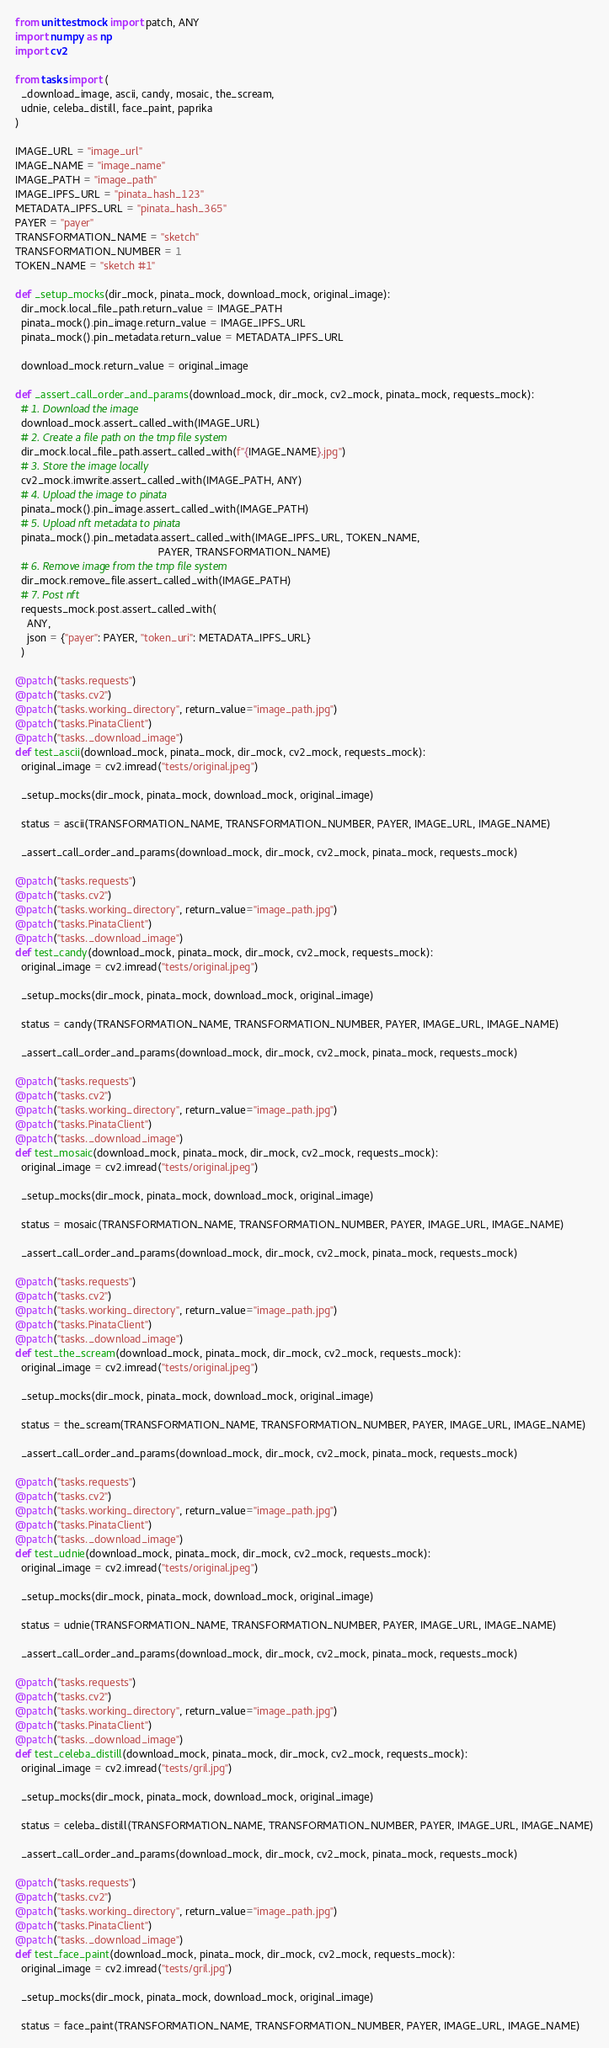<code> <loc_0><loc_0><loc_500><loc_500><_Python_>from unittest.mock import patch, ANY
import numpy as np
import cv2

from tasks import (
  _download_image, ascii, candy, mosaic, the_scream,
  udnie, celeba_distill, face_paint, paprika
)

IMAGE_URL = "image_url"
IMAGE_NAME = "image_name"
IMAGE_PATH = "image_path"
IMAGE_IPFS_URL = "pinata_hash_123"
METADATA_IPFS_URL = "pinata_hash_365"
PAYER = "payer"
TRANSFORMATION_NAME = "sketch"
TRANSFORMATION_NUMBER = 1
TOKEN_NAME = "sketch #1"

def _setup_mocks(dir_mock, pinata_mock, download_mock, original_image):
  dir_mock.local_file_path.return_value = IMAGE_PATH
  pinata_mock().pin_image.return_value = IMAGE_IPFS_URL
  pinata_mock().pin_metadata.return_value = METADATA_IPFS_URL

  download_mock.return_value = original_image

def _assert_call_order_and_params(download_mock, dir_mock, cv2_mock, pinata_mock, requests_mock):
  # 1. Download the image
  download_mock.assert_called_with(IMAGE_URL)
  # 2. Create a file path on the tmp file system
  dir_mock.local_file_path.assert_called_with(f"{IMAGE_NAME}.jpg")
  # 3. Store the image locally
  cv2_mock.imwrite.assert_called_with(IMAGE_PATH, ANY)
  # 4. Upload the image to pinata
  pinata_mock().pin_image.assert_called_with(IMAGE_PATH)
  # 5. Upload nft metadata to pinata
  pinata_mock().pin_metadata.assert_called_with(IMAGE_IPFS_URL, TOKEN_NAME,
                                                PAYER, TRANSFORMATION_NAME)
  # 6. Remove image from the tmp file system
  dir_mock.remove_file.assert_called_with(IMAGE_PATH)
  # 7. Post nft
  requests_mock.post.assert_called_with(
    ANY,
    json = {"payer": PAYER, "token_uri": METADATA_IPFS_URL}
  )

@patch("tasks.requests")
@patch("tasks.cv2")
@patch("tasks.working_directory", return_value="image_path.jpg")
@patch("tasks.PinataClient")
@patch("tasks._download_image")
def test_ascii(download_mock, pinata_mock, dir_mock, cv2_mock, requests_mock):
  original_image = cv2.imread("tests/original.jpeg")

  _setup_mocks(dir_mock, pinata_mock, download_mock, original_image)

  status = ascii(TRANSFORMATION_NAME, TRANSFORMATION_NUMBER, PAYER, IMAGE_URL, IMAGE_NAME)

  _assert_call_order_and_params(download_mock, dir_mock, cv2_mock, pinata_mock, requests_mock)

@patch("tasks.requests")
@patch("tasks.cv2")
@patch("tasks.working_directory", return_value="image_path.jpg")
@patch("tasks.PinataClient")
@patch("tasks._download_image")
def test_candy(download_mock, pinata_mock, dir_mock, cv2_mock, requests_mock):
  original_image = cv2.imread("tests/original.jpeg")

  _setup_mocks(dir_mock, pinata_mock, download_mock, original_image)

  status = candy(TRANSFORMATION_NAME, TRANSFORMATION_NUMBER, PAYER, IMAGE_URL, IMAGE_NAME)

  _assert_call_order_and_params(download_mock, dir_mock, cv2_mock, pinata_mock, requests_mock)

@patch("tasks.requests")
@patch("tasks.cv2")
@patch("tasks.working_directory", return_value="image_path.jpg")
@patch("tasks.PinataClient")
@patch("tasks._download_image")
def test_mosaic(download_mock, pinata_mock, dir_mock, cv2_mock, requests_mock):
  original_image = cv2.imread("tests/original.jpeg")

  _setup_mocks(dir_mock, pinata_mock, download_mock, original_image)

  status = mosaic(TRANSFORMATION_NAME, TRANSFORMATION_NUMBER, PAYER, IMAGE_URL, IMAGE_NAME)

  _assert_call_order_and_params(download_mock, dir_mock, cv2_mock, pinata_mock, requests_mock)

@patch("tasks.requests")
@patch("tasks.cv2")
@patch("tasks.working_directory", return_value="image_path.jpg")
@patch("tasks.PinataClient")
@patch("tasks._download_image")
def test_the_scream(download_mock, pinata_mock, dir_mock, cv2_mock, requests_mock):
  original_image = cv2.imread("tests/original.jpeg")

  _setup_mocks(dir_mock, pinata_mock, download_mock, original_image)

  status = the_scream(TRANSFORMATION_NAME, TRANSFORMATION_NUMBER, PAYER, IMAGE_URL, IMAGE_NAME)

  _assert_call_order_and_params(download_mock, dir_mock, cv2_mock, pinata_mock, requests_mock)

@patch("tasks.requests")
@patch("tasks.cv2")
@patch("tasks.working_directory", return_value="image_path.jpg")
@patch("tasks.PinataClient")
@patch("tasks._download_image")
def test_udnie(download_mock, pinata_mock, dir_mock, cv2_mock, requests_mock):
  original_image = cv2.imread("tests/original.jpeg")

  _setup_mocks(dir_mock, pinata_mock, download_mock, original_image)

  status = udnie(TRANSFORMATION_NAME, TRANSFORMATION_NUMBER, PAYER, IMAGE_URL, IMAGE_NAME)

  _assert_call_order_and_params(download_mock, dir_mock, cv2_mock, pinata_mock, requests_mock)

@patch("tasks.requests")
@patch("tasks.cv2")
@patch("tasks.working_directory", return_value="image_path.jpg")
@patch("tasks.PinataClient")
@patch("tasks._download_image")
def test_celeba_distill(download_mock, pinata_mock, dir_mock, cv2_mock, requests_mock):
  original_image = cv2.imread("tests/gril.jpg")

  _setup_mocks(dir_mock, pinata_mock, download_mock, original_image)

  status = celeba_distill(TRANSFORMATION_NAME, TRANSFORMATION_NUMBER, PAYER, IMAGE_URL, IMAGE_NAME)

  _assert_call_order_and_params(download_mock, dir_mock, cv2_mock, pinata_mock, requests_mock)

@patch("tasks.requests")
@patch("tasks.cv2")
@patch("tasks.working_directory", return_value="image_path.jpg")
@patch("tasks.PinataClient")
@patch("tasks._download_image")
def test_face_paint(download_mock, pinata_mock, dir_mock, cv2_mock, requests_mock):
  original_image = cv2.imread("tests/gril.jpg")

  _setup_mocks(dir_mock, pinata_mock, download_mock, original_image)

  status = face_paint(TRANSFORMATION_NAME, TRANSFORMATION_NUMBER, PAYER, IMAGE_URL, IMAGE_NAME)
</code> 